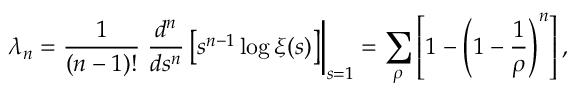Convert formula to latex. <formula><loc_0><loc_0><loc_500><loc_500>\lambda _ { n } = { \frac { 1 } { ( n - 1 ) ! } } { \frac { d ^ { n } } { d s ^ { n } } } \left [ s ^ { n - 1 } \log \xi ( s ) \right ] \right | _ { s = 1 } = \sum _ { \rho } \left [ 1 - \left ( 1 - { \frac { 1 } { \rho } } \right ) ^ { n } \right ] ,</formula> 